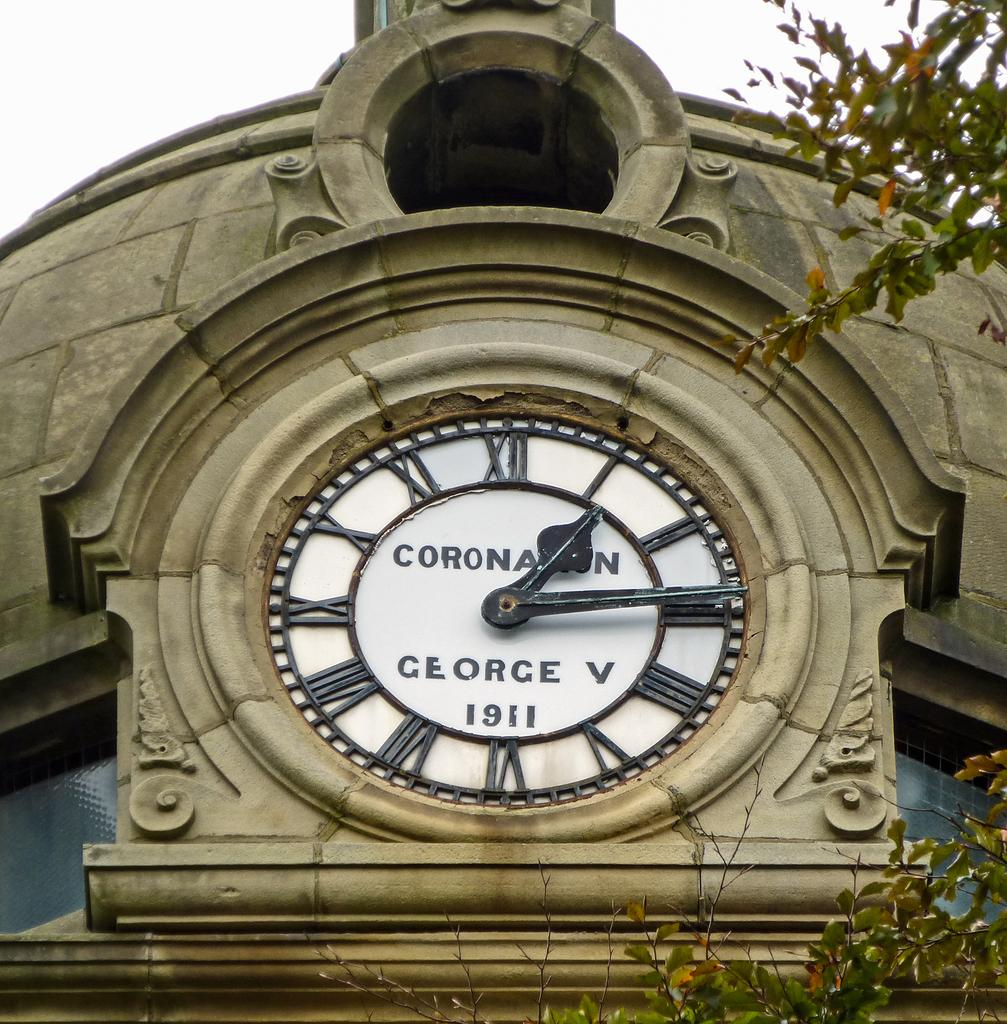<image>
Offer a succinct explanation of the picture presented. A clock from 1911 shows the time is 1:15. 